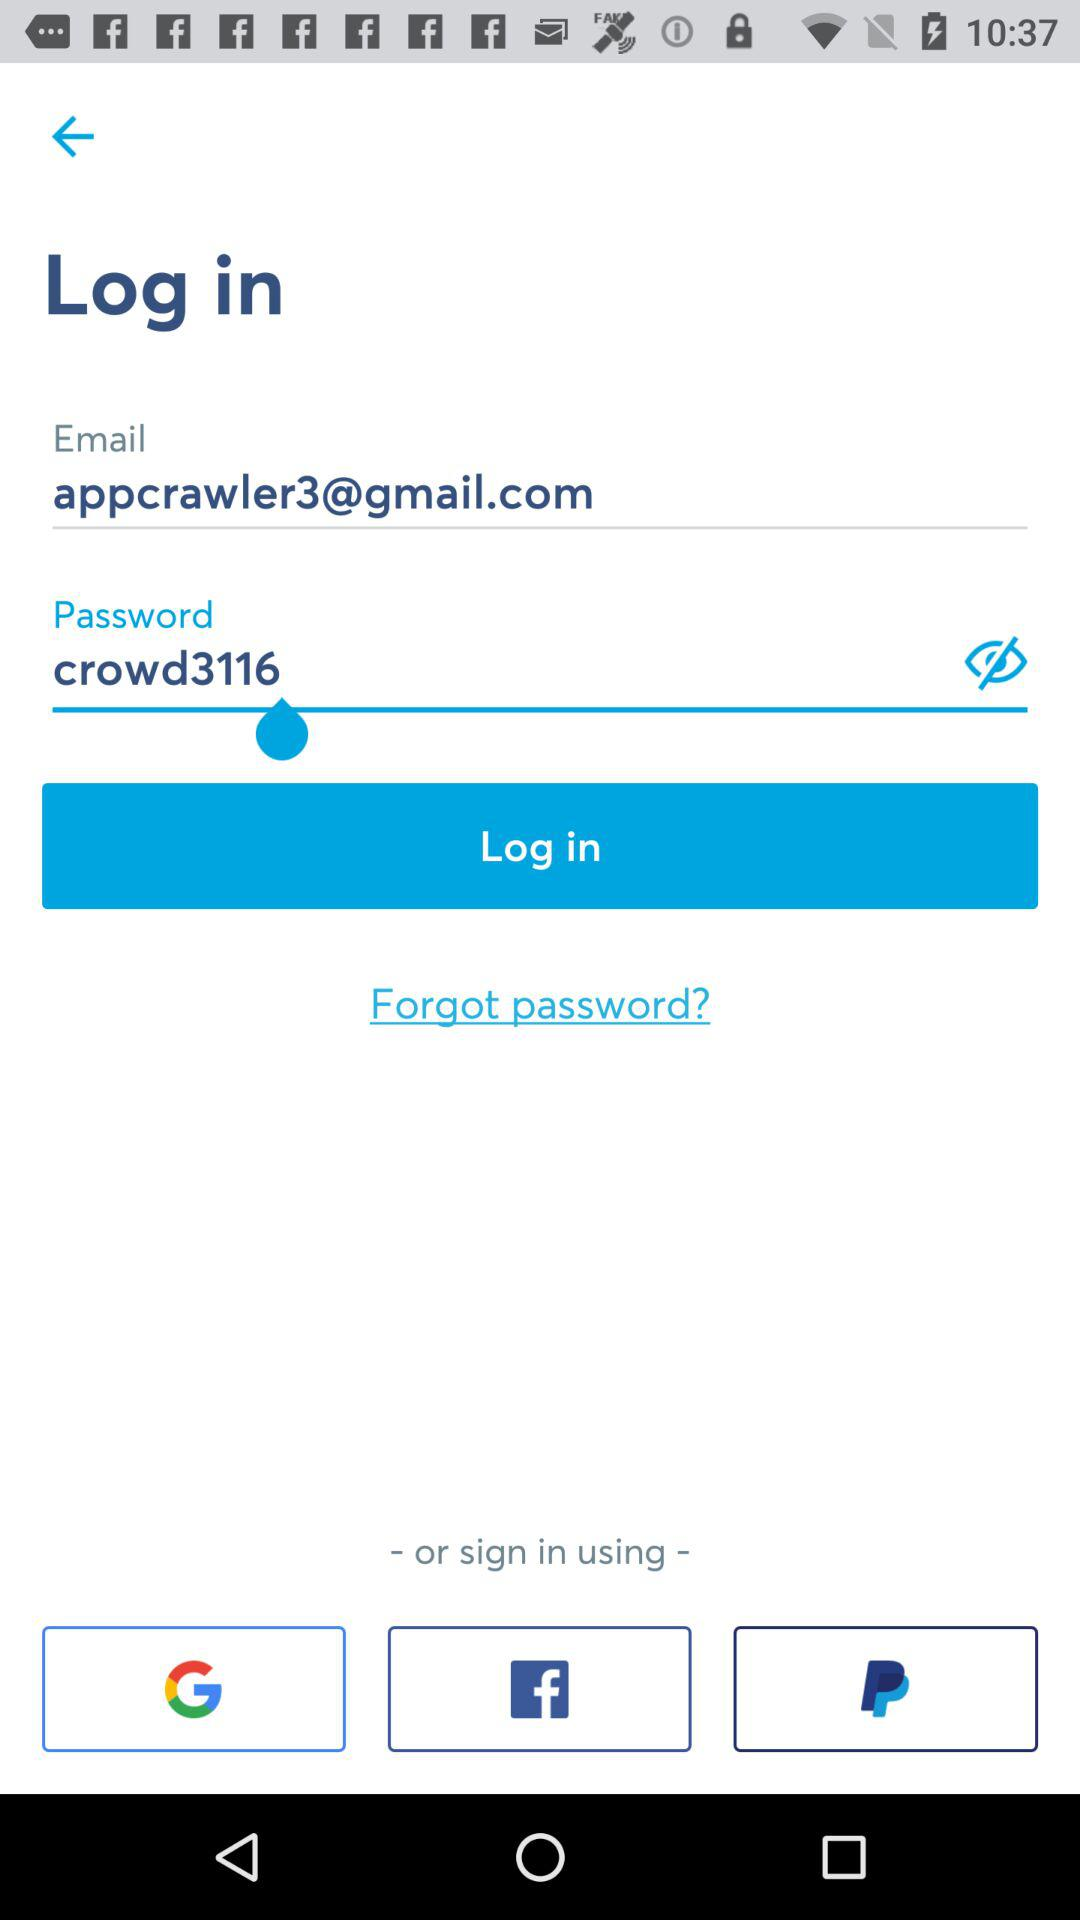How many fields are required to log in?
Answer the question using a single word or phrase. 2 